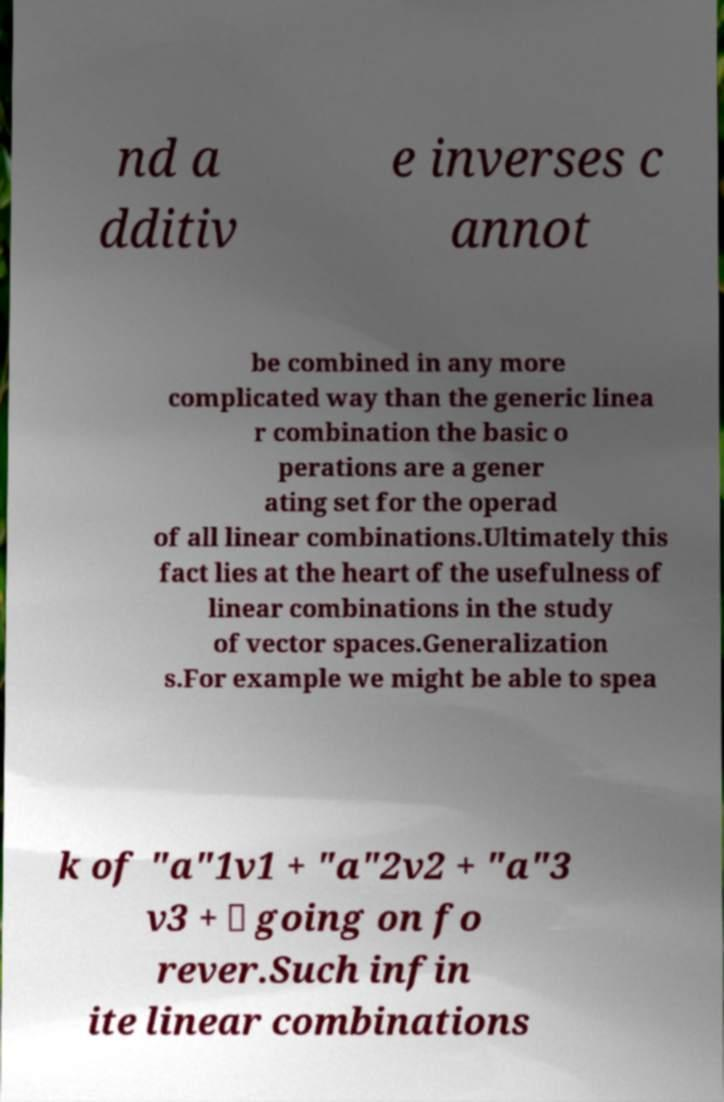Can you accurately transcribe the text from the provided image for me? nd a dditiv e inverses c annot be combined in any more complicated way than the generic linea r combination the basic o perations are a gener ating set for the operad of all linear combinations.Ultimately this fact lies at the heart of the usefulness of linear combinations in the study of vector spaces.Generalization s.For example we might be able to spea k of "a"1v1 + "a"2v2 + "a"3 v3 + ⋯ going on fo rever.Such infin ite linear combinations 